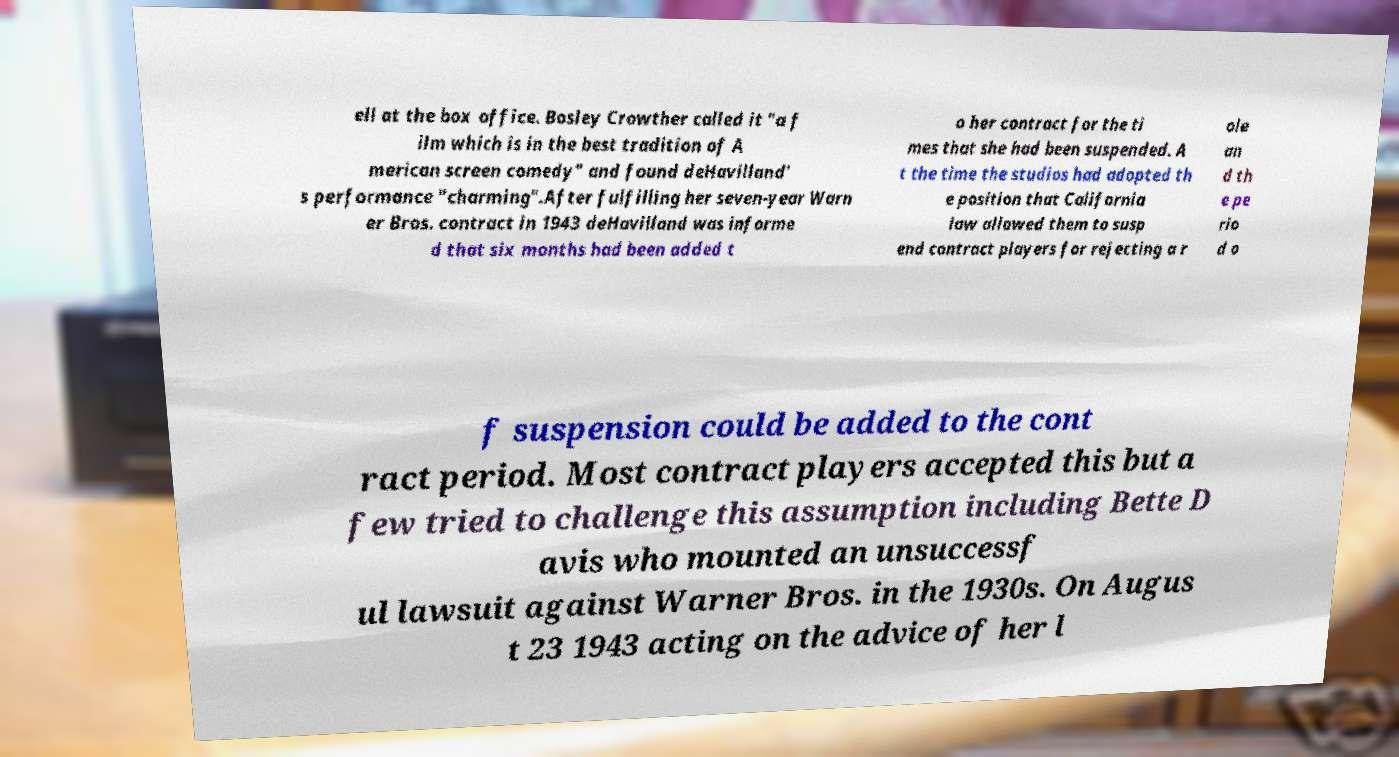For documentation purposes, I need the text within this image transcribed. Could you provide that? ell at the box office. Bosley Crowther called it "a f ilm which is in the best tradition of A merican screen comedy" and found deHavilland' s performance "charming".After fulfilling her seven-year Warn er Bros. contract in 1943 deHavilland was informe d that six months had been added t o her contract for the ti mes that she had been suspended. A t the time the studios had adopted th e position that California law allowed them to susp end contract players for rejecting a r ole an d th e pe rio d o f suspension could be added to the cont ract period. Most contract players accepted this but a few tried to challenge this assumption including Bette D avis who mounted an unsuccessf ul lawsuit against Warner Bros. in the 1930s. On Augus t 23 1943 acting on the advice of her l 